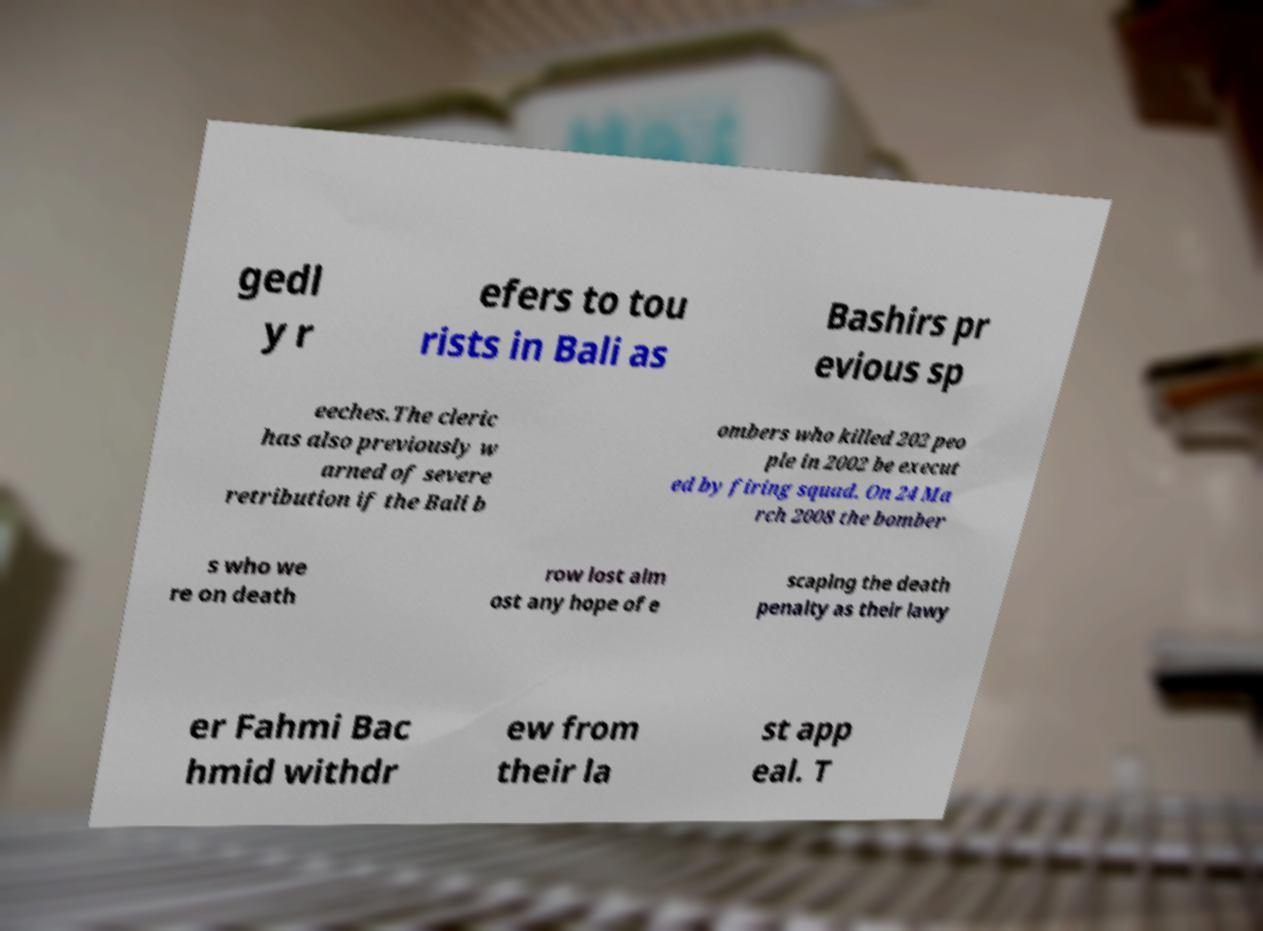Please read and relay the text visible in this image. What does it say? gedl y r efers to tou rists in Bali as Bashirs pr evious sp eeches.The cleric has also previously w arned of severe retribution if the Bali b ombers who killed 202 peo ple in 2002 be execut ed by firing squad. On 24 Ma rch 2008 the bomber s who we re on death row lost alm ost any hope of e scaping the death penalty as their lawy er Fahmi Bac hmid withdr ew from their la st app eal. T 